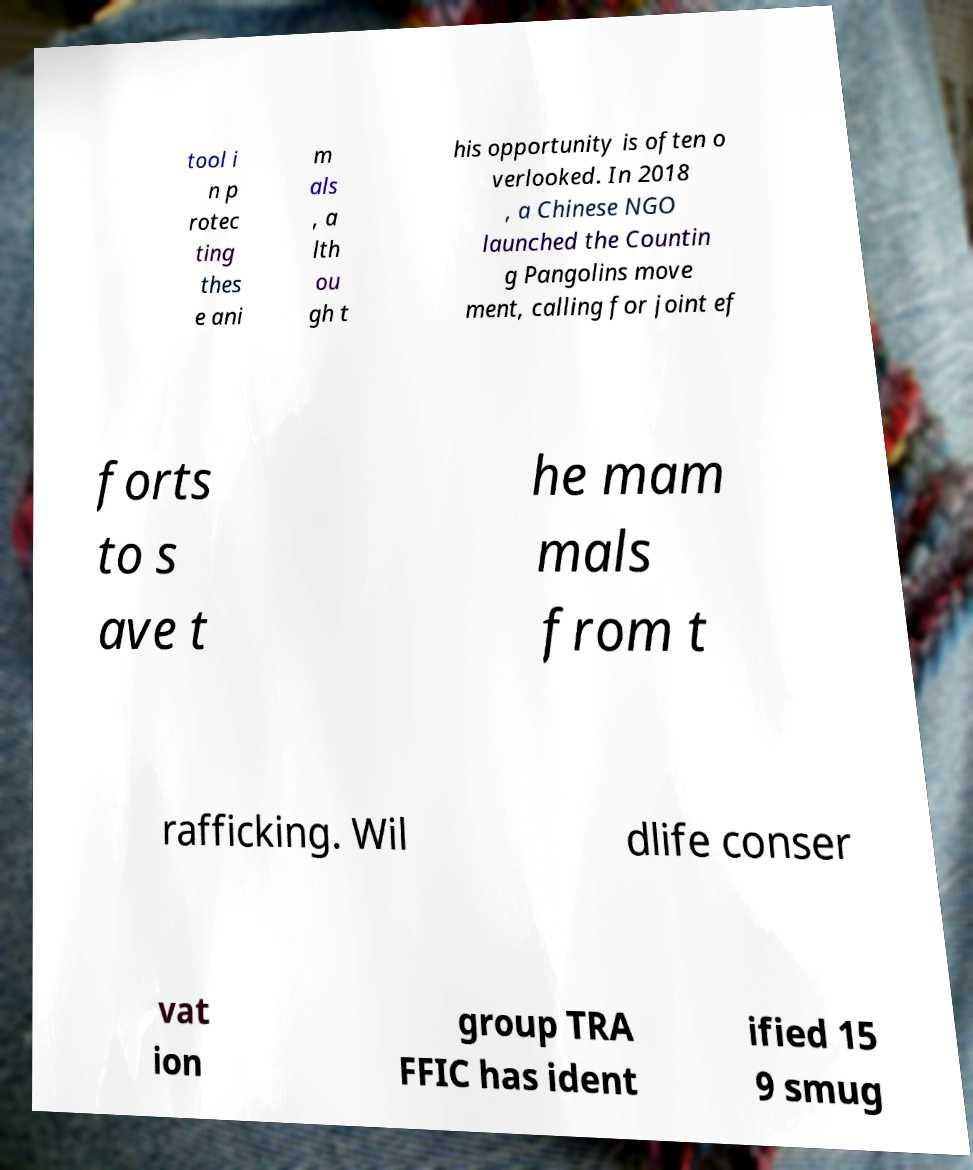Can you read and provide the text displayed in the image?This photo seems to have some interesting text. Can you extract and type it out for me? tool i n p rotec ting thes e ani m als , a lth ou gh t his opportunity is often o verlooked. In 2018 , a Chinese NGO launched the Countin g Pangolins move ment, calling for joint ef forts to s ave t he mam mals from t rafficking. Wil dlife conser vat ion group TRA FFIC has ident ified 15 9 smug 